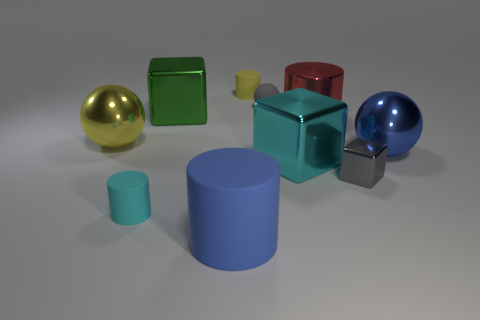Subtract all big metal blocks. How many blocks are left? 1 Subtract all green cubes. How many cubes are left? 2 Subtract 1 cyan cylinders. How many objects are left? 9 Subtract all cylinders. How many objects are left? 6 Subtract all blue cylinders. Subtract all brown balls. How many cylinders are left? 3 Subtract all yellow balls. How many cyan blocks are left? 1 Subtract all red metallic spheres. Subtract all yellow metal spheres. How many objects are left? 9 Add 5 big yellow balls. How many big yellow balls are left? 6 Add 7 large green things. How many large green things exist? 8 